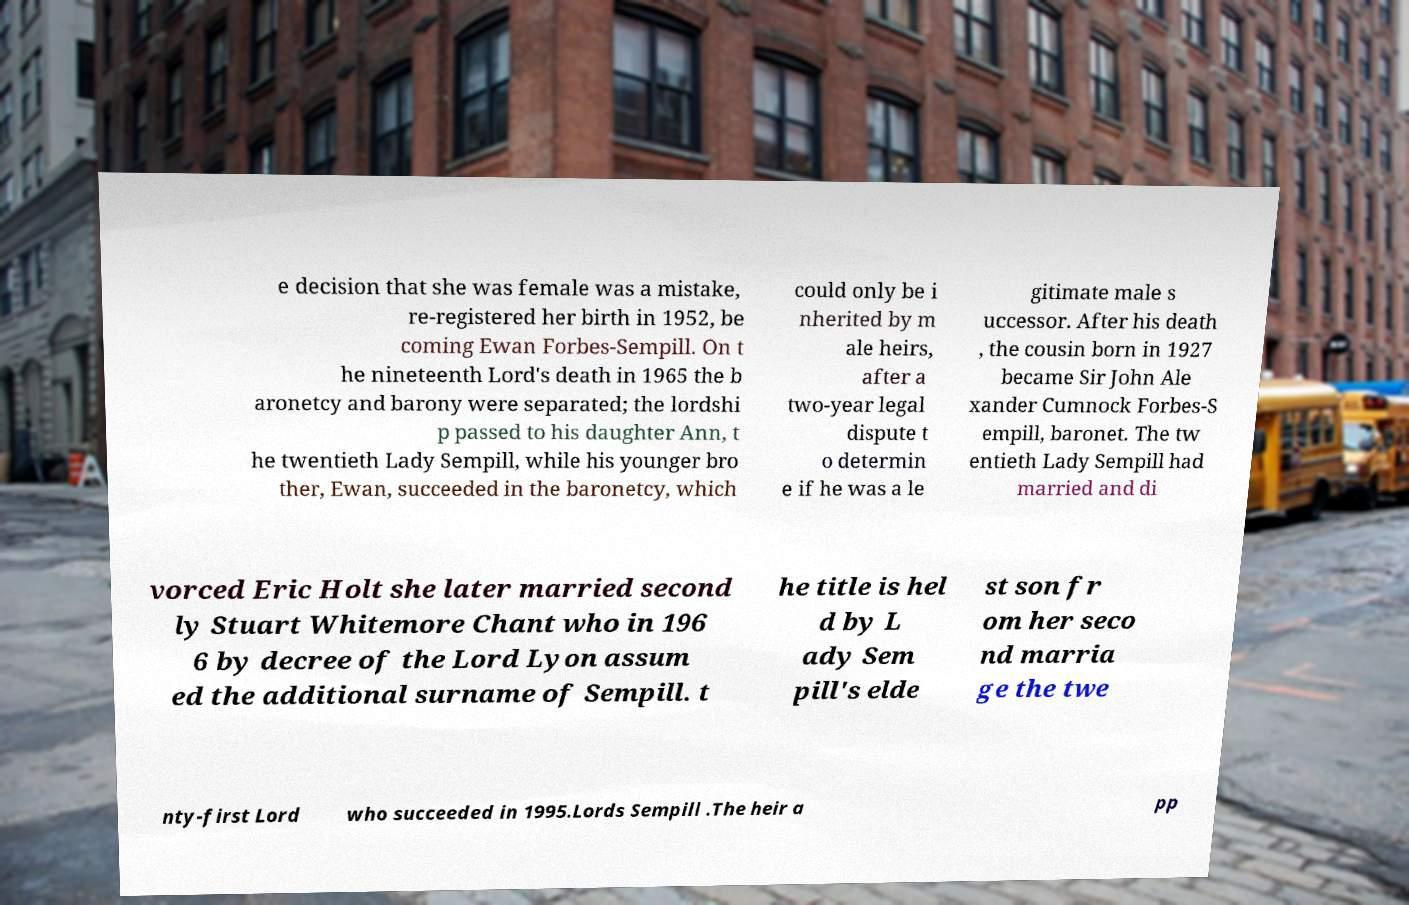Can you accurately transcribe the text from the provided image for me? e decision that she was female was a mistake, re-registered her birth in 1952, be coming Ewan Forbes-Sempill. On t he nineteenth Lord's death in 1965 the b aronetcy and barony were separated; the lordshi p passed to his daughter Ann, t he twentieth Lady Sempill, while his younger bro ther, Ewan, succeeded in the baronetcy, which could only be i nherited by m ale heirs, after a two-year legal dispute t o determin e if he was a le gitimate male s uccessor. After his death , the cousin born in 1927 became Sir John Ale xander Cumnock Forbes-S empill, baronet. The tw entieth Lady Sempill had married and di vorced Eric Holt she later married second ly Stuart Whitemore Chant who in 196 6 by decree of the Lord Lyon assum ed the additional surname of Sempill. t he title is hel d by L ady Sem pill's elde st son fr om her seco nd marria ge the twe nty-first Lord who succeeded in 1995.Lords Sempill .The heir a pp 